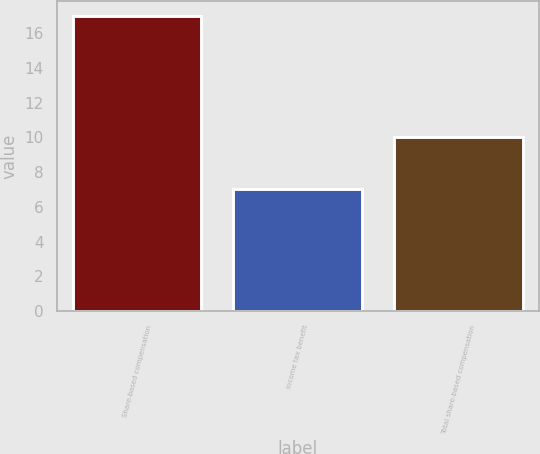<chart> <loc_0><loc_0><loc_500><loc_500><bar_chart><fcel>Share-based compensation<fcel>Income tax benefit<fcel>Total share-based compensation<nl><fcel>17<fcel>7<fcel>10<nl></chart> 